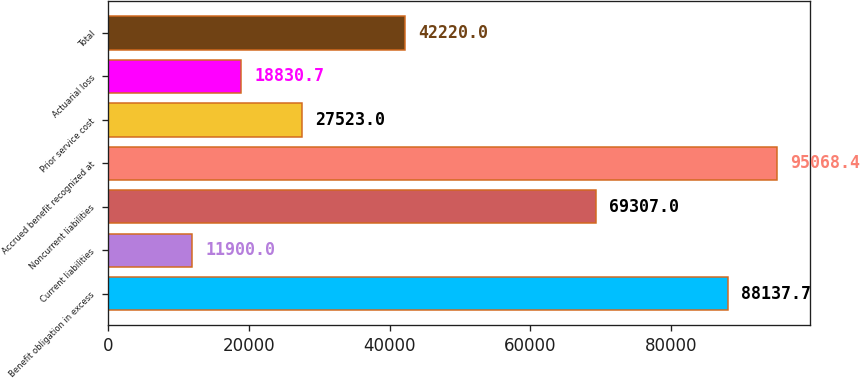Convert chart. <chart><loc_0><loc_0><loc_500><loc_500><bar_chart><fcel>Benefit obligation in excess<fcel>Current liabilities<fcel>Noncurrent liabilities<fcel>Accrued benefit recognized at<fcel>Prior service cost<fcel>Actuarial loss<fcel>Total<nl><fcel>88137.7<fcel>11900<fcel>69307<fcel>95068.4<fcel>27523<fcel>18830.7<fcel>42220<nl></chart> 